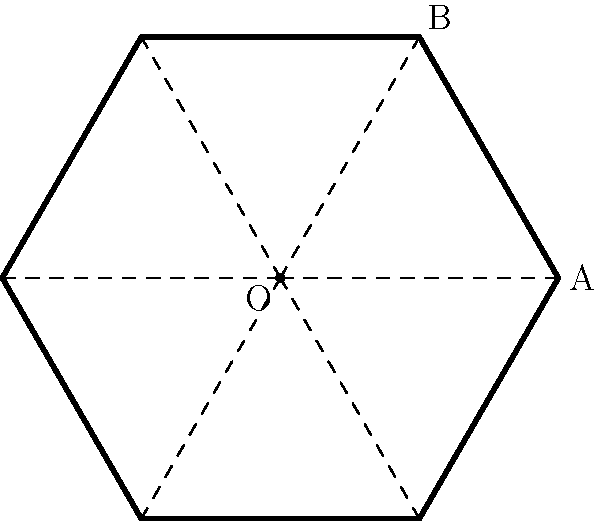A hexagonal gong used in traditional Nagaland drumming is represented by the figure above. If the gong is rotated clockwise about its center O by an angle of $60^\circ$, how many times will it coincide with its original position during one complete rotation of $360^\circ$? To solve this problem, let's consider the properties of a regular hexagon:

1. A regular hexagon has 6 sides and 6 vertices.
2. The internal angles of a regular hexagon are each $120^\circ$.
3. The hexagon has rotational symmetry of order 6, meaning it can be rotated by $360^\circ / 6 = 60^\circ$ to coincide with its original position.

Now, let's analyze the rotation:

1. The gong is rotated by $60^\circ$ clockwise each time.
2. To complete one full rotation, we need to rotate $360^\circ$.
3. The number of times the gong will coincide with its original position is:
   $$ \text{Number of coincidences} = \frac{360^\circ}{60^\circ} = 6 $$

Therefore, during one complete rotation of $360^\circ$, the hexagonal gong will coincide with its original position 6 times, including the starting and ending positions.
Answer: 6 times 